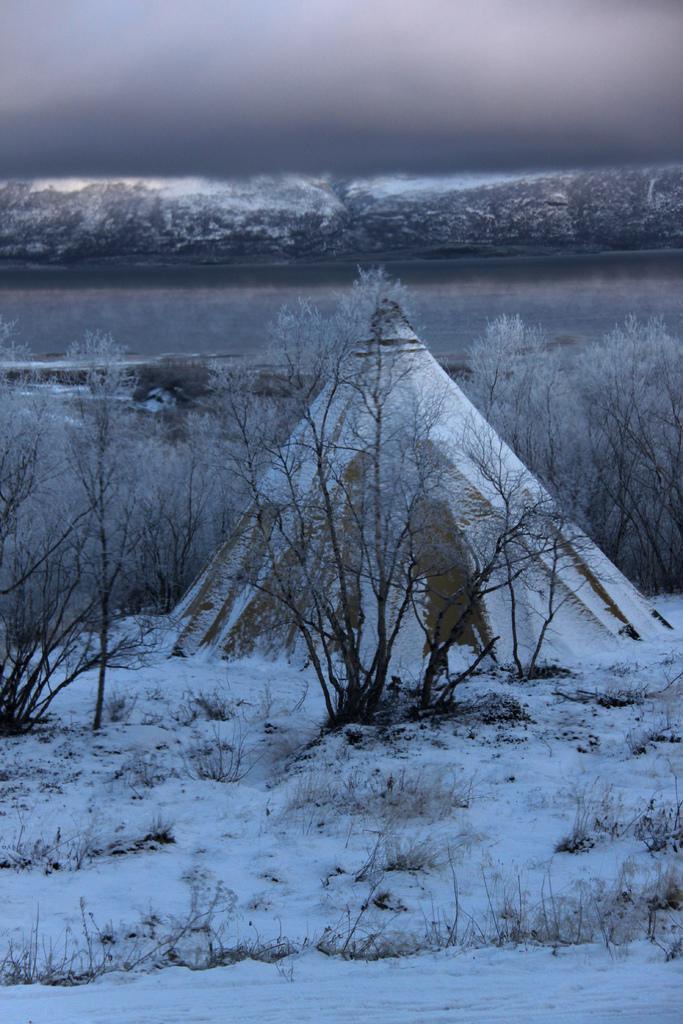How would you summarize this image in a sentence or two? This picture shows trees and we see grass on the ground and snow. We see water and a cloudy sky. 